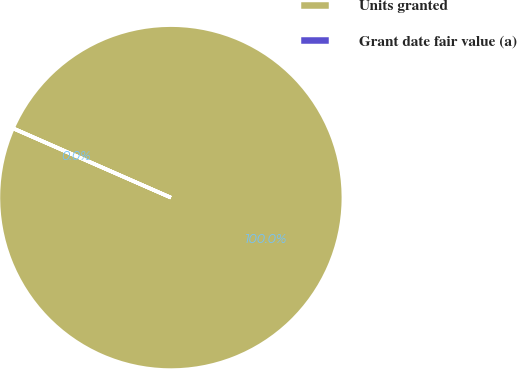<chart> <loc_0><loc_0><loc_500><loc_500><pie_chart><fcel>Units granted<fcel>Grant date fair value (a)<nl><fcel>99.98%<fcel>0.02%<nl></chart> 